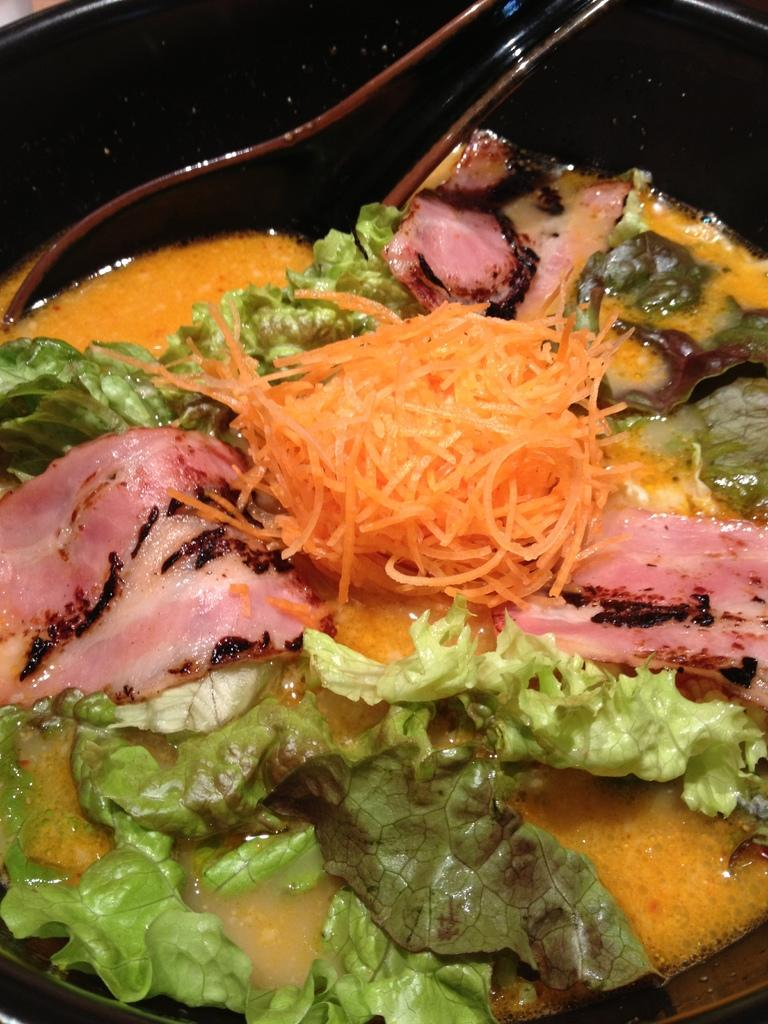What is in the bowl that is visible in the image? There is a bowl with food in the image. Can you describe the appearance of the food? The food is colorful. What color is the bowl? The bowl is black. What utensil is present in the bowl? There is a spoon in the bowl. What type of pest can be seen crawling on the food in the image? There are no pests visible in the image; the food appears to be clean and untouched. 